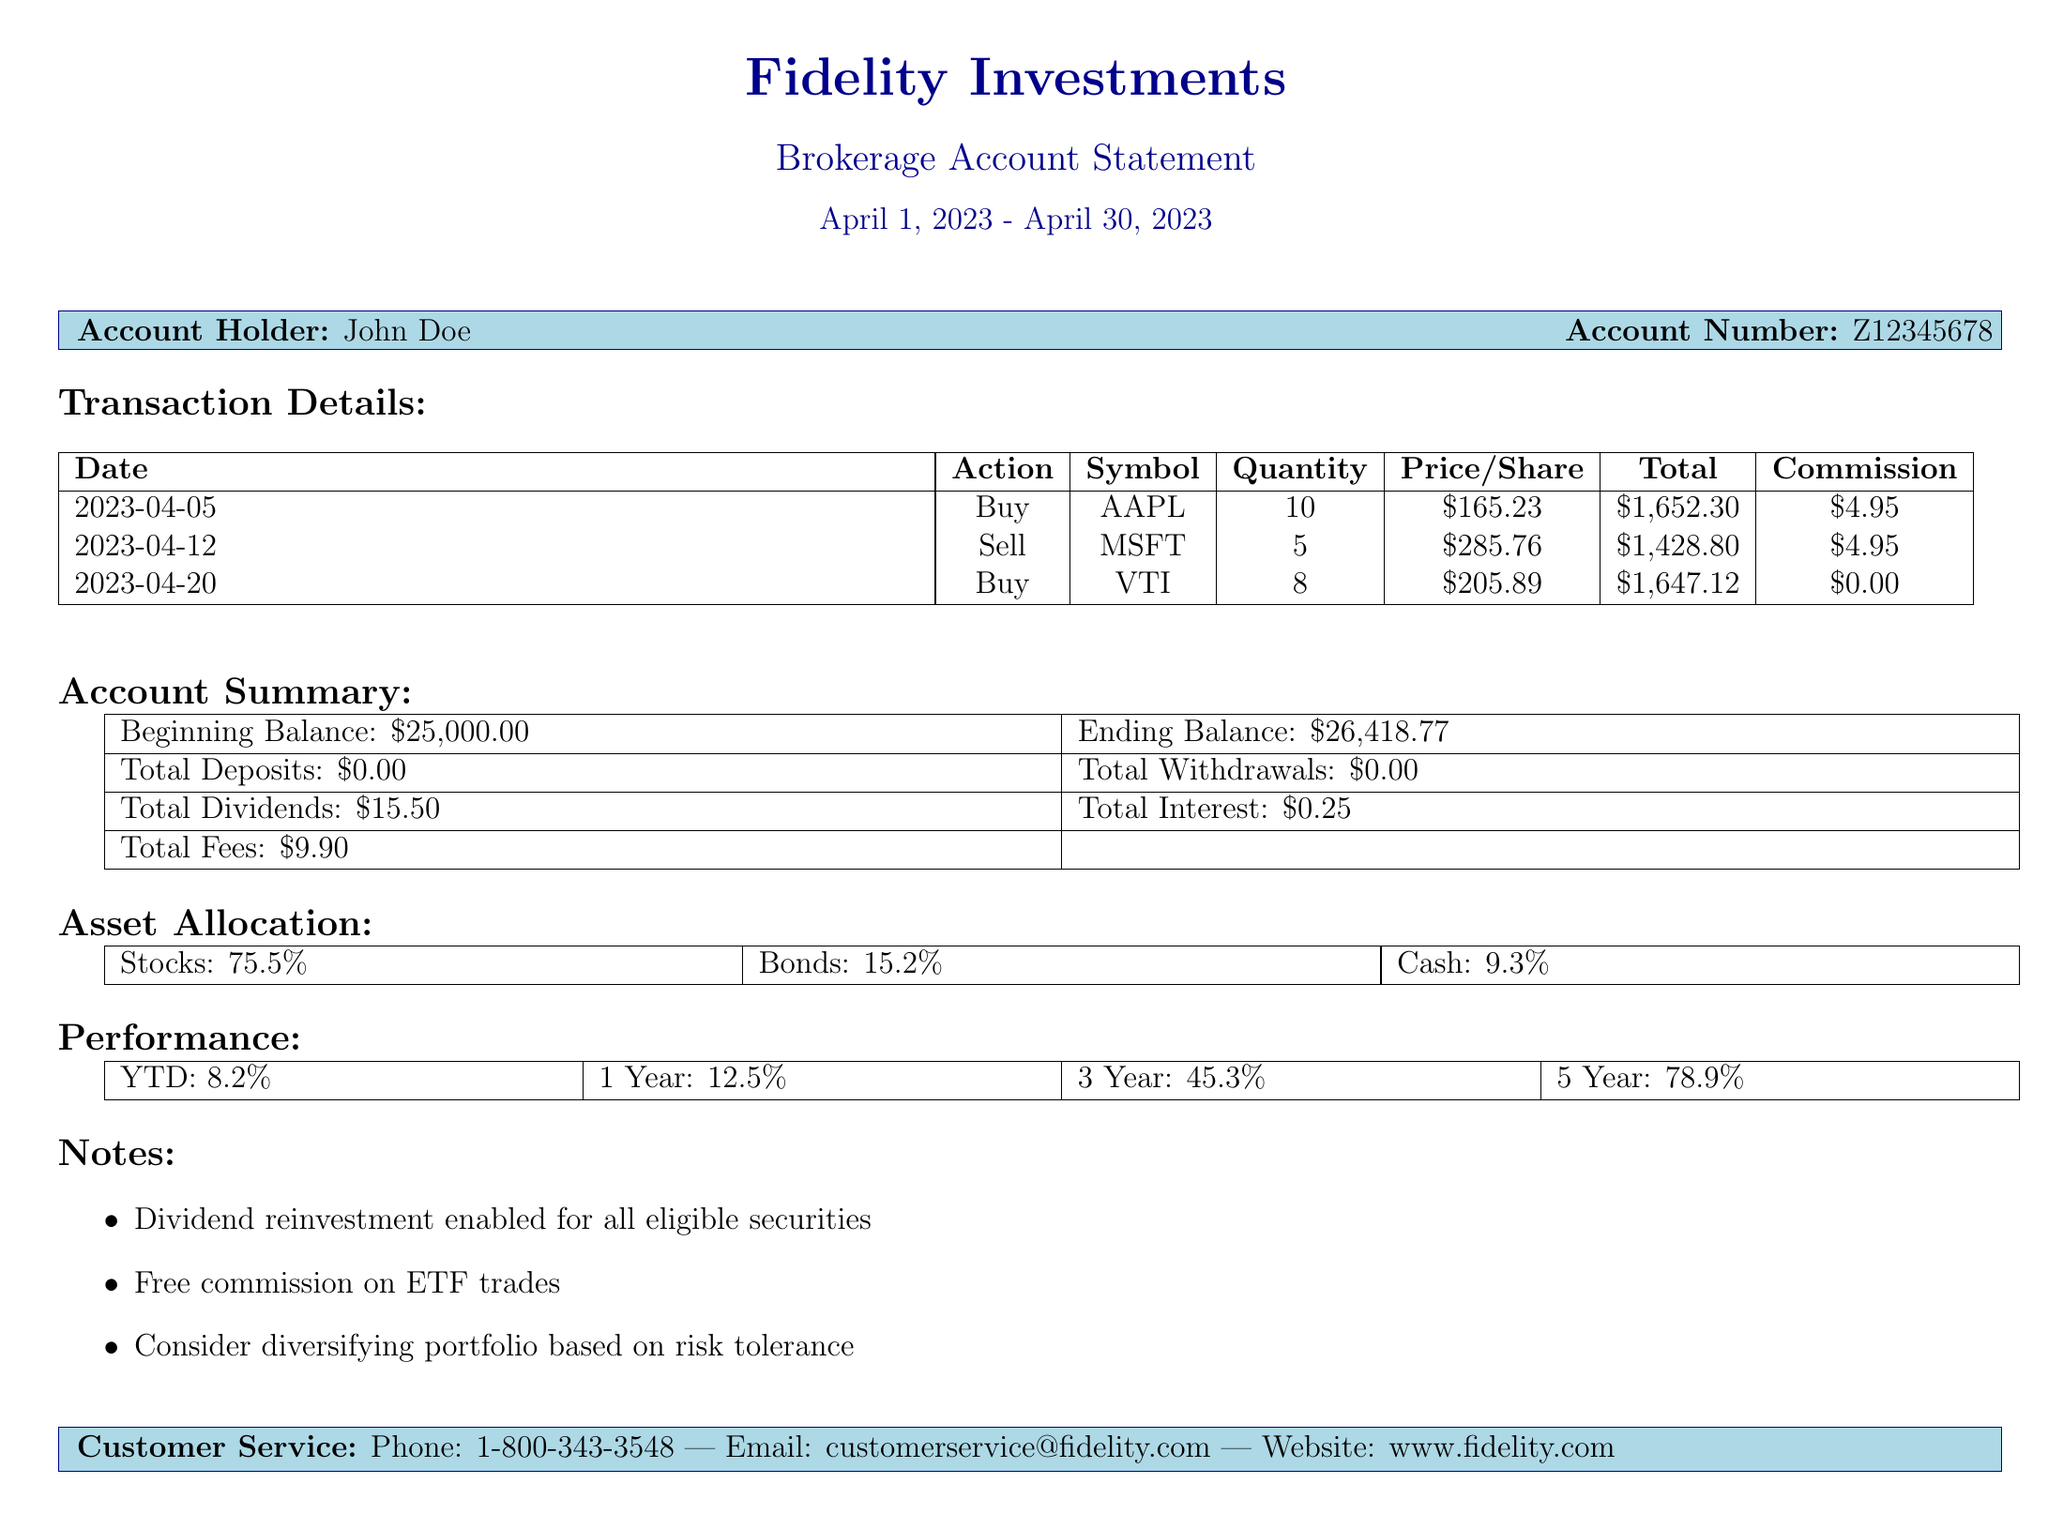What is the brokerage firm? The document specifies that the brokerage firm is Fidelity Investments.
Answer: Fidelity Investments Who is the account holder? The document indicates that the account holder's name is John Doe.
Answer: John Doe What was the total amount for the AAPL transaction? For the AAPL transaction on April 5, 2023, the total amount is clearly stated as $1,652.30.
Answer: $1,652.30 What is the commission for the MSFT sale? The document lists the commission for the MSFT sale as $4.95.
Answer: $4.95 What is the ending balance of the account? The ending balance for the account is given as $26,418.77 in the summary section.
Answer: $26,418.77 What percentage of the asset allocation is in stocks? The document shows that stocks make up 75.5% of the asset allocation.
Answer: 75.5% How much total fees were incurred? The account summary section indicates total fees are $9.90.
Answer: $9.90 What is the year-to-date performance percentage? According to the performance section, the year-to-date percentage is mentioned as 8.2%.
Answer: 8.2% What transaction had no commission? The buy transaction for VTI on April 20, 2023, is noted to have a commission of $0.00.
Answer: VTI 